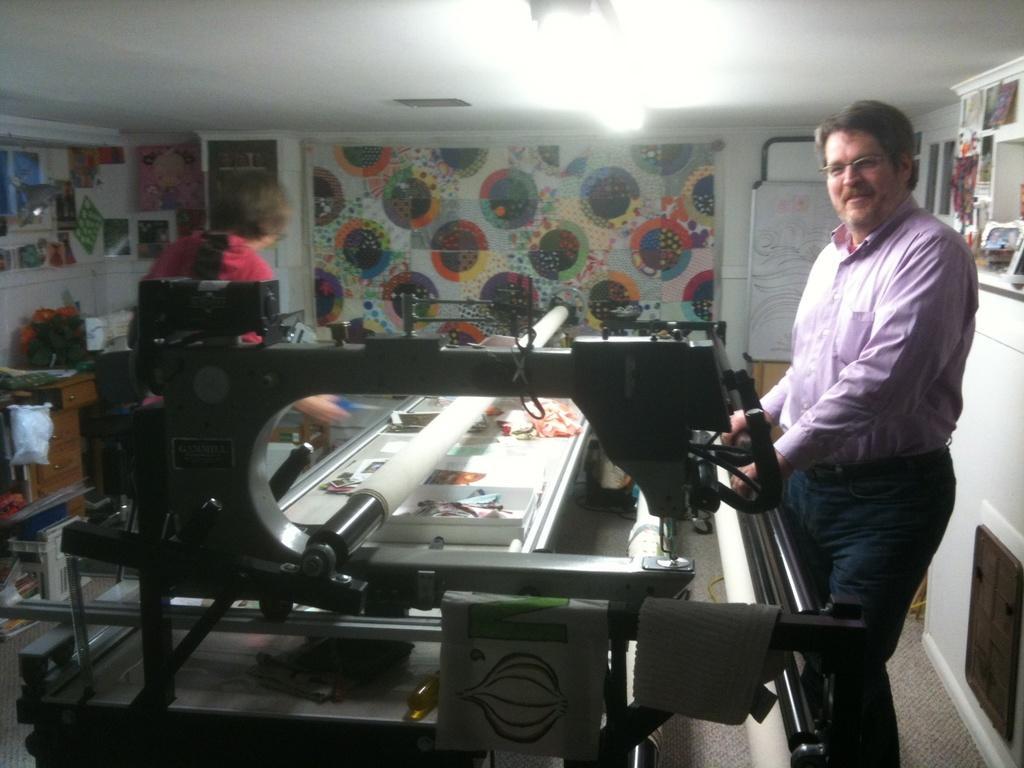Can you describe this image briefly? The picture is taken in a room. In the center of the picture there is a banner printing machine. On the right there is a person standing. In the background there are posters, boat and many objects to the wall. On the left there is a person standing, beside her there are flowers, desk and many other objects. At the top it is ceiling. There is a light to the ceiling. 